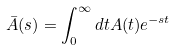<formula> <loc_0><loc_0><loc_500><loc_500>\bar { A } ( s ) = \int _ { 0 } ^ { \infty } d t A ( t ) e ^ { - s t }</formula> 